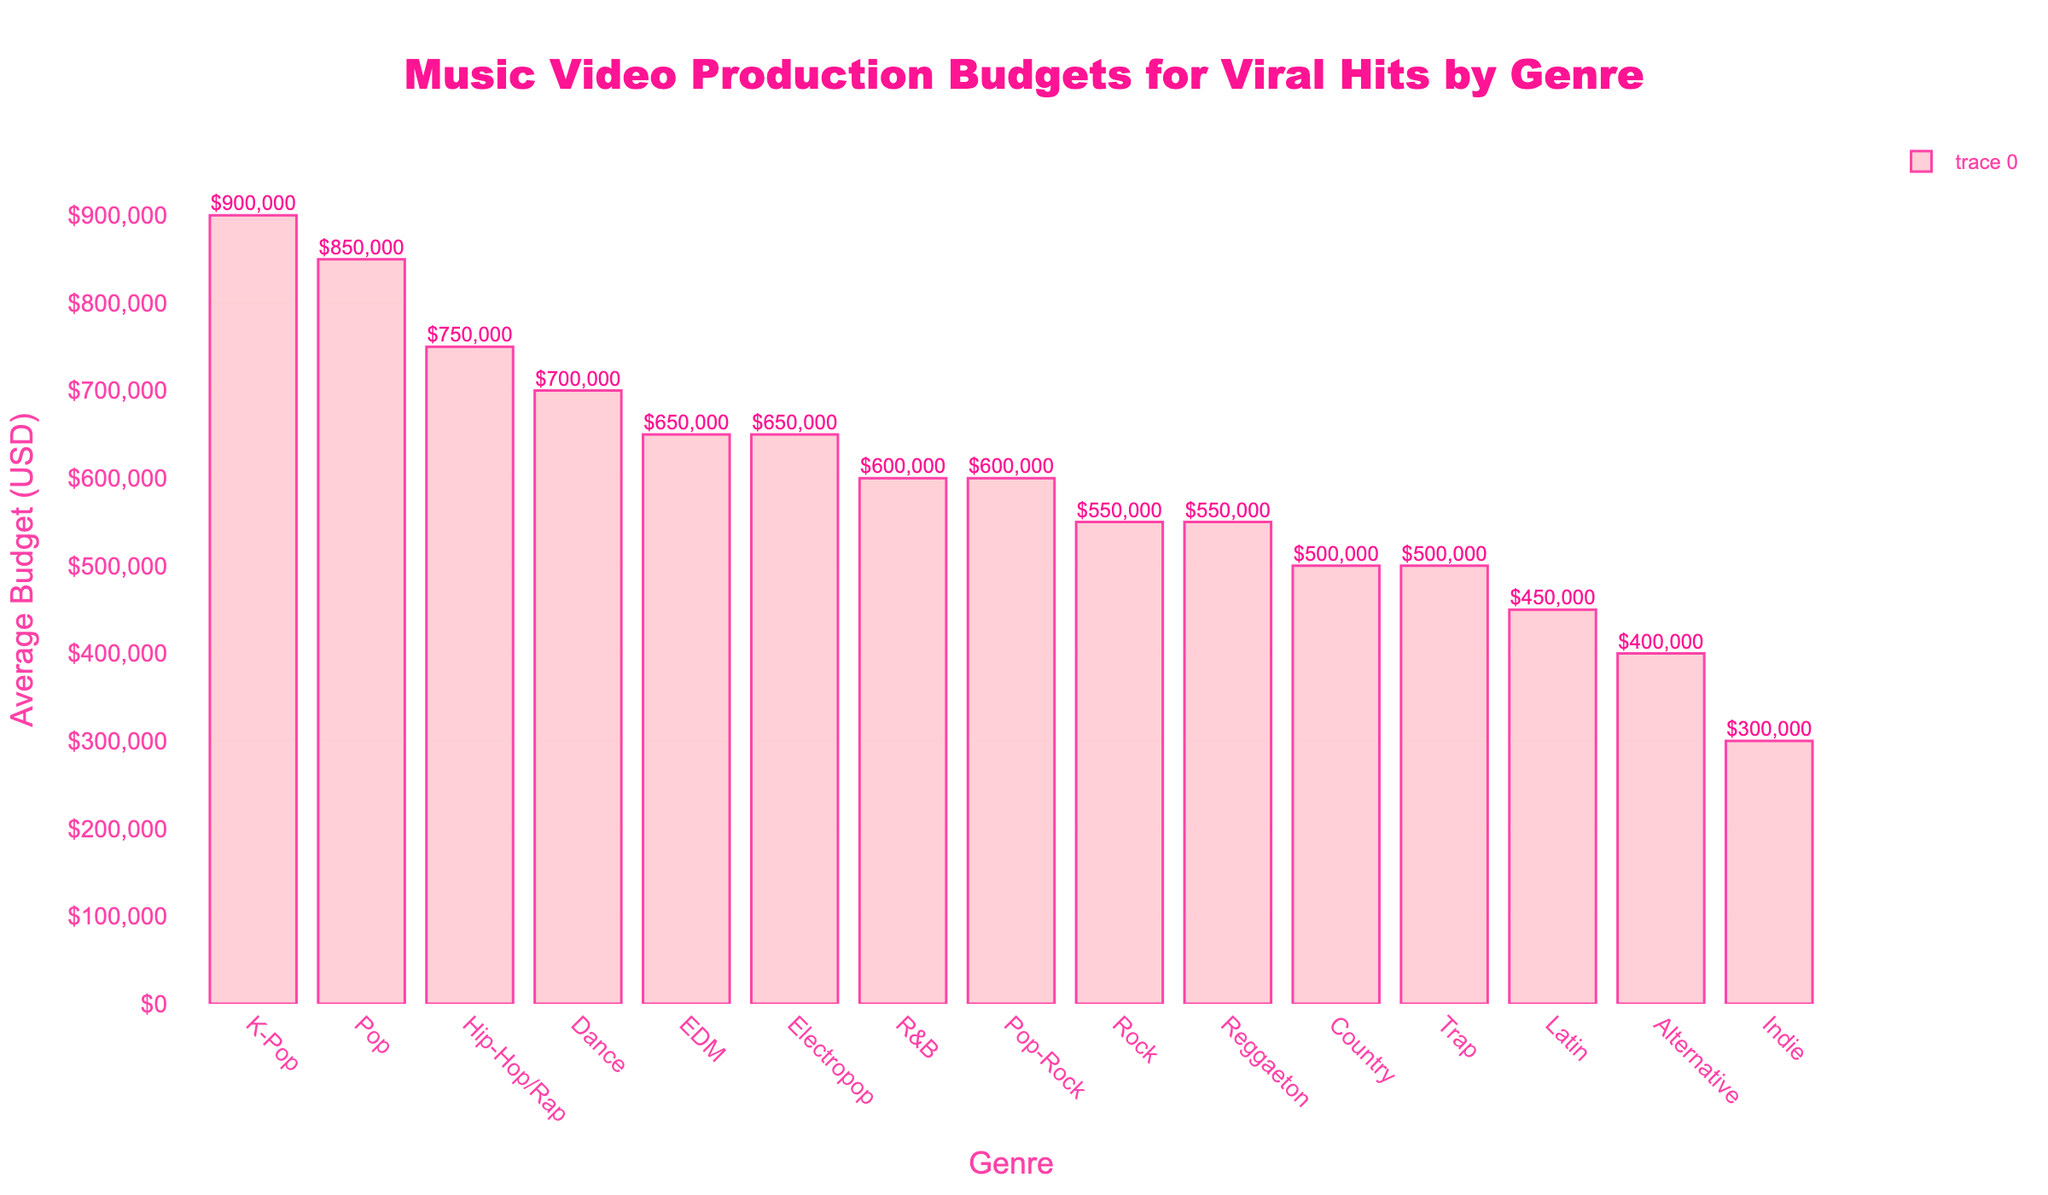Which genre has the highest average budget for music video production? The figure shows the bar heights for various genres, with the highest bar indicating the genre with the highest average budget. In the figure, K-Pop has the highest bar.
Answer: K-Pop Which genre has a lower average budget for music video production, Rock or R&B? The figure compares the bar heights for Rock and R&B. Rock has a bar height corresponding to $550,000 while R&B has a bar height of $600,000, so Rock has a lower average budget.
Answer: Rock By how much is Pop's average budget higher than Country's? The figure shows Pop's average budget is $850,000 and Country's is $500,000. The difference is $850,000 - $500,000.
Answer: $350,000 What is the combined average budget for Dance and EDM genres? The figure demonstrates Dance's average budget is $700,000 and EDM's is $650,000. The combined budget is $700,000 + $650,000.
Answer: $1,350,000 Among Hip-Hop/Rap, EDM, and Electropop, which genre has the highest average budget for music video production? The figure shows the average budgets for Hip-Hop/Rap at $750,000, EDM at $650,000, and Electropop at $650,000. Hip-Hop/Rap has the highest average budget among these.
Answer: Hip-Hop/Rap What is the average budget for Pop-Rock genre? The figure shows a bar representing the average budget for Pop-Rock, marked at $600,000.
Answer: $600,000 Which genre ranks third in terms of average budget for music video production? By ordering the bars from highest to lowest, Pop is first, K-Pop is second, and Hip-Hop/Rap is third.
Answer: Hip-Hop/Rap Is the average budget for Indie higher or lower than Alternative? By how much? The figure shows Indie’s average budget is $300,000 and Alternative’s is $400,000. Indie’s budget is lower by $400,000 - $300,000.
Answer: $100,000 lower Are there more genres with an average budget above or below $600,000? Counting the number of bars above $600,000 (Pop, K-Pop, Hip-Hop/Rap, Dance) and below $600,000 (EDM, R&B, Rock, Country, Latin, Indie, Alternative, Reggaeton, Trap, Electropop), there are more genres below $600,000.
Answer: Below What's the difference in average budget between the highest and lowest genres? The figure shows K-Pop at $900,000 and Indie at $300,000. The difference is $900,000 - $300,000.
Answer: $600,000 